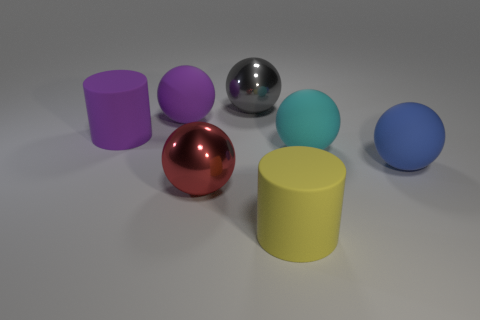What material is the big purple object that is the same shape as the yellow rubber object?
Offer a very short reply. Rubber. Are any cyan spheres visible?
Keep it short and to the point. Yes. What is the material of the cylinder that is behind the big matte cylinder that is to the right of the large cylinder to the left of the yellow rubber cylinder?
Offer a terse response. Rubber. Is the shape of the gray thing the same as the purple thing that is right of the purple rubber cylinder?
Provide a succinct answer. Yes. What number of other large things are the same shape as the red metallic thing?
Offer a terse response. 4. There is a blue rubber object; what shape is it?
Ensure brevity in your answer.  Sphere. What number of things are either gray objects or large yellow cylinders?
Make the answer very short. 2. Is the big gray metallic thing the same shape as the red shiny object?
Offer a terse response. Yes. Are there any big red objects made of the same material as the red ball?
Offer a very short reply. No. Are there any red metallic balls on the left side of the big matte cylinder behind the yellow cylinder?
Your answer should be compact. No. 